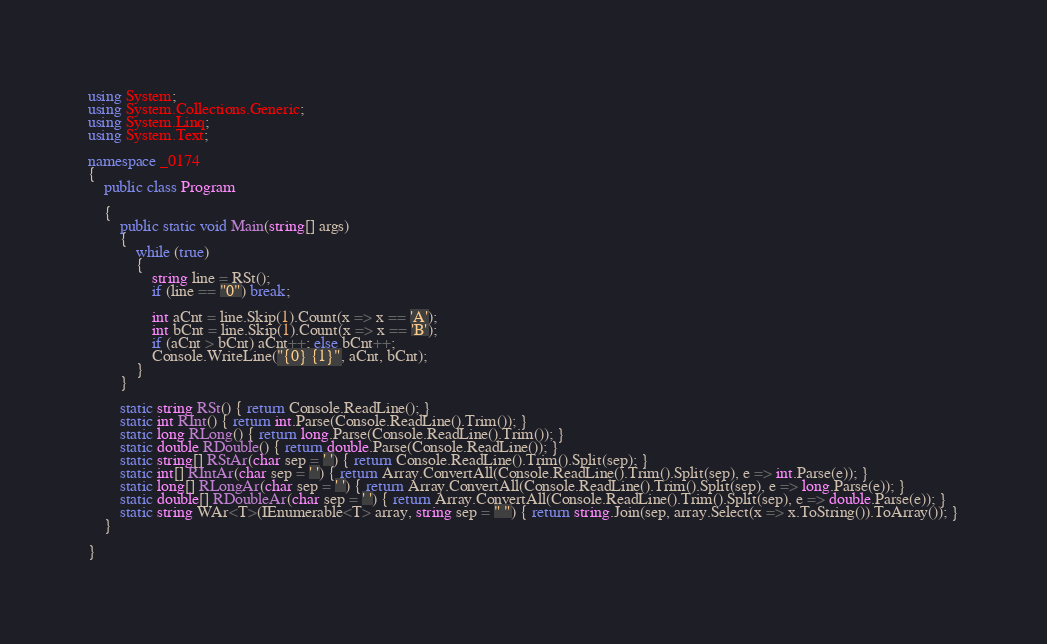<code> <loc_0><loc_0><loc_500><loc_500><_C#_>using System;
using System.Collections.Generic;
using System.Linq;
using System.Text;

namespace _0174
{
    public class Program

    {
        public static void Main(string[] args)
        {
            while (true)
            {
                string line = RSt();
                if (line == "0") break;

                int aCnt = line.Skip(1).Count(x => x == 'A');
                int bCnt = line.Skip(1).Count(x => x == 'B');
                if (aCnt > bCnt) aCnt++; else bCnt++;
                Console.WriteLine("{0} {1}", aCnt, bCnt);
            }
        }

        static string RSt() { return Console.ReadLine(); }
        static int RInt() { return int.Parse(Console.ReadLine().Trim()); }
        static long RLong() { return long.Parse(Console.ReadLine().Trim()); }
        static double RDouble() { return double.Parse(Console.ReadLine()); }
        static string[] RStAr(char sep = ' ') { return Console.ReadLine().Trim().Split(sep); }
        static int[] RIntAr(char sep = ' ') { return Array.ConvertAll(Console.ReadLine().Trim().Split(sep), e => int.Parse(e)); }
        static long[] RLongAr(char sep = ' ') { return Array.ConvertAll(Console.ReadLine().Trim().Split(sep), e => long.Parse(e)); }
        static double[] RDoubleAr(char sep = ' ') { return Array.ConvertAll(Console.ReadLine().Trim().Split(sep), e => double.Parse(e)); }
        static string WAr<T>(IEnumerable<T> array, string sep = " ") { return string.Join(sep, array.Select(x => x.ToString()).ToArray()); }
    }

}

</code> 